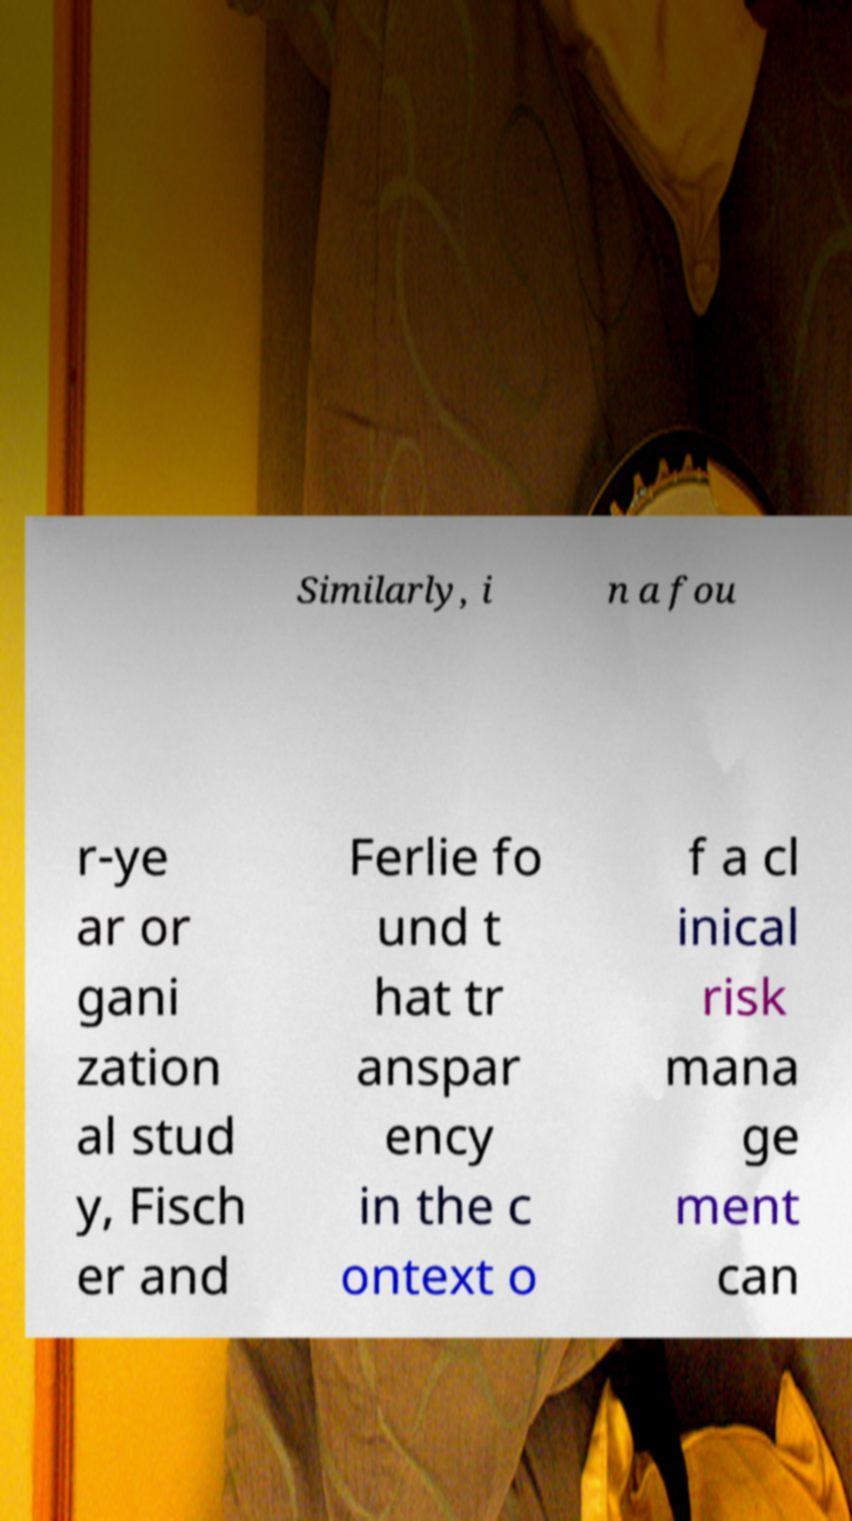Please identify and transcribe the text found in this image. Similarly, i n a fou r-ye ar or gani zation al stud y, Fisch er and Ferlie fo und t hat tr anspar ency in the c ontext o f a cl inical risk mana ge ment can 